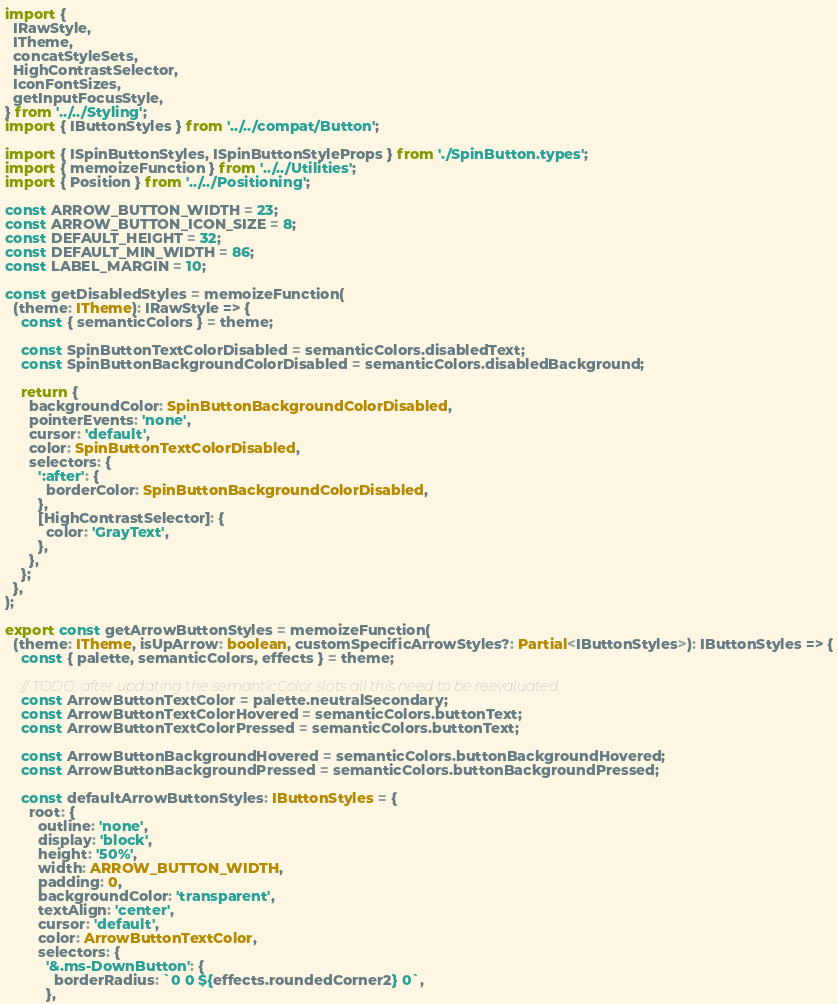Convert code to text. <code><loc_0><loc_0><loc_500><loc_500><_TypeScript_>import {
  IRawStyle,
  ITheme,
  concatStyleSets,
  HighContrastSelector,
  IconFontSizes,
  getInputFocusStyle,
} from '../../Styling';
import { IButtonStyles } from '../../compat/Button';

import { ISpinButtonStyles, ISpinButtonStyleProps } from './SpinButton.types';
import { memoizeFunction } from '../../Utilities';
import { Position } from '../../Positioning';

const ARROW_BUTTON_WIDTH = 23;
const ARROW_BUTTON_ICON_SIZE = 8;
const DEFAULT_HEIGHT = 32;
const DEFAULT_MIN_WIDTH = 86;
const LABEL_MARGIN = 10;

const getDisabledStyles = memoizeFunction(
  (theme: ITheme): IRawStyle => {
    const { semanticColors } = theme;

    const SpinButtonTextColorDisabled = semanticColors.disabledText;
    const SpinButtonBackgroundColorDisabled = semanticColors.disabledBackground;

    return {
      backgroundColor: SpinButtonBackgroundColorDisabled,
      pointerEvents: 'none',
      cursor: 'default',
      color: SpinButtonTextColorDisabled,
      selectors: {
        ':after': {
          borderColor: SpinButtonBackgroundColorDisabled,
        },
        [HighContrastSelector]: {
          color: 'GrayText',
        },
      },
    };
  },
);

export const getArrowButtonStyles = memoizeFunction(
  (theme: ITheme, isUpArrow: boolean, customSpecificArrowStyles?: Partial<IButtonStyles>): IButtonStyles => {
    const { palette, semanticColors, effects } = theme;

    // TODO: after updating the semanticColor slots all this need to be reevaluated.
    const ArrowButtonTextColor = palette.neutralSecondary;
    const ArrowButtonTextColorHovered = semanticColors.buttonText;
    const ArrowButtonTextColorPressed = semanticColors.buttonText;

    const ArrowButtonBackgroundHovered = semanticColors.buttonBackgroundHovered;
    const ArrowButtonBackgroundPressed = semanticColors.buttonBackgroundPressed;

    const defaultArrowButtonStyles: IButtonStyles = {
      root: {
        outline: 'none',
        display: 'block',
        height: '50%',
        width: ARROW_BUTTON_WIDTH,
        padding: 0,
        backgroundColor: 'transparent',
        textAlign: 'center',
        cursor: 'default',
        color: ArrowButtonTextColor,
        selectors: {
          '&.ms-DownButton': {
            borderRadius: `0 0 ${effects.roundedCorner2} 0`,
          },</code> 